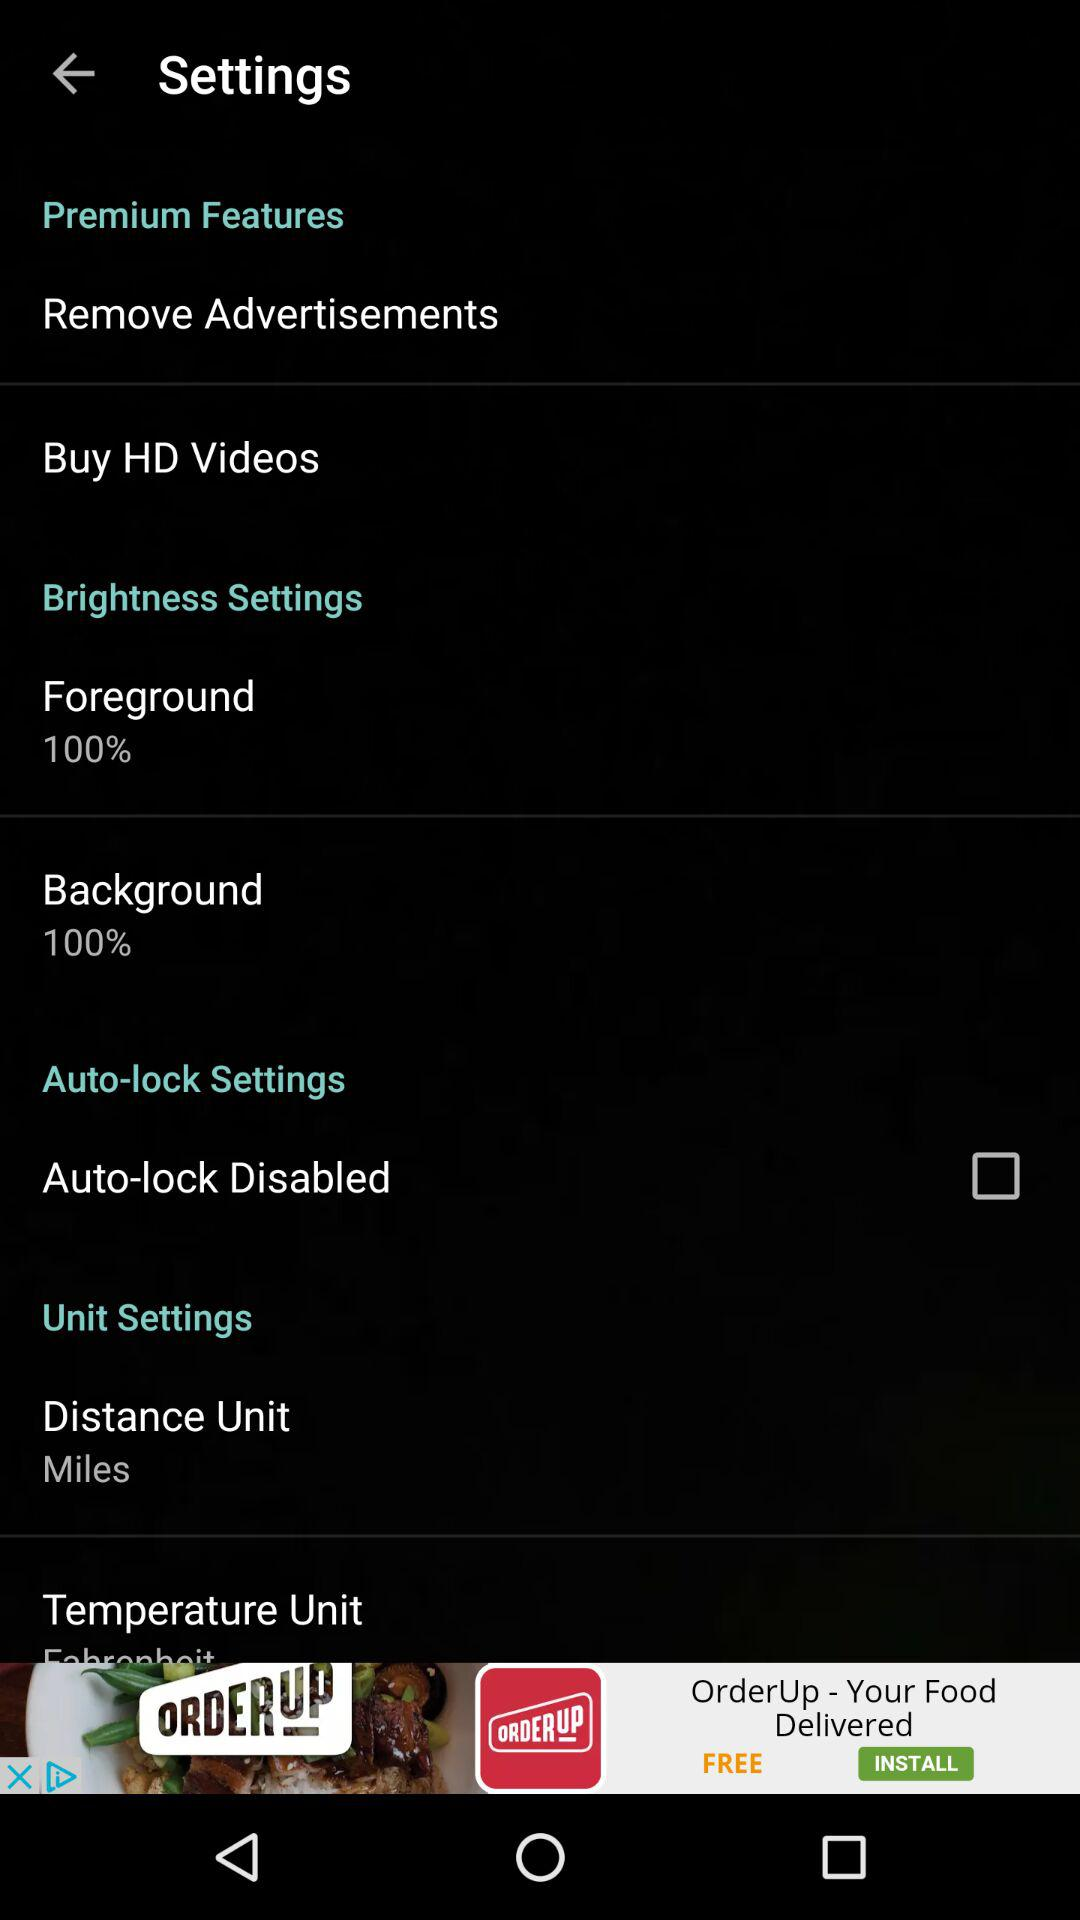How much brightness has been set for the background? The brightness that has been set for the background is 100%. 